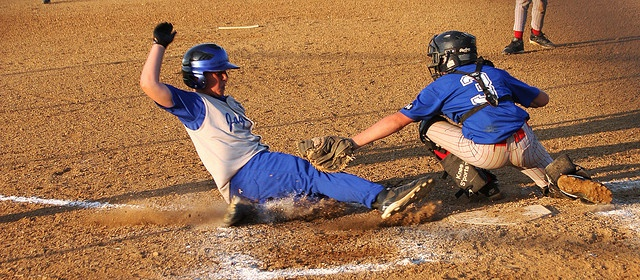Describe the objects in this image and their specific colors. I can see people in red, black, blue, maroon, and gray tones, people in red, black, blue, and navy tones, baseball glove in red, gray, tan, brown, and black tones, and people in red, black, tan, maroon, and gray tones in this image. 